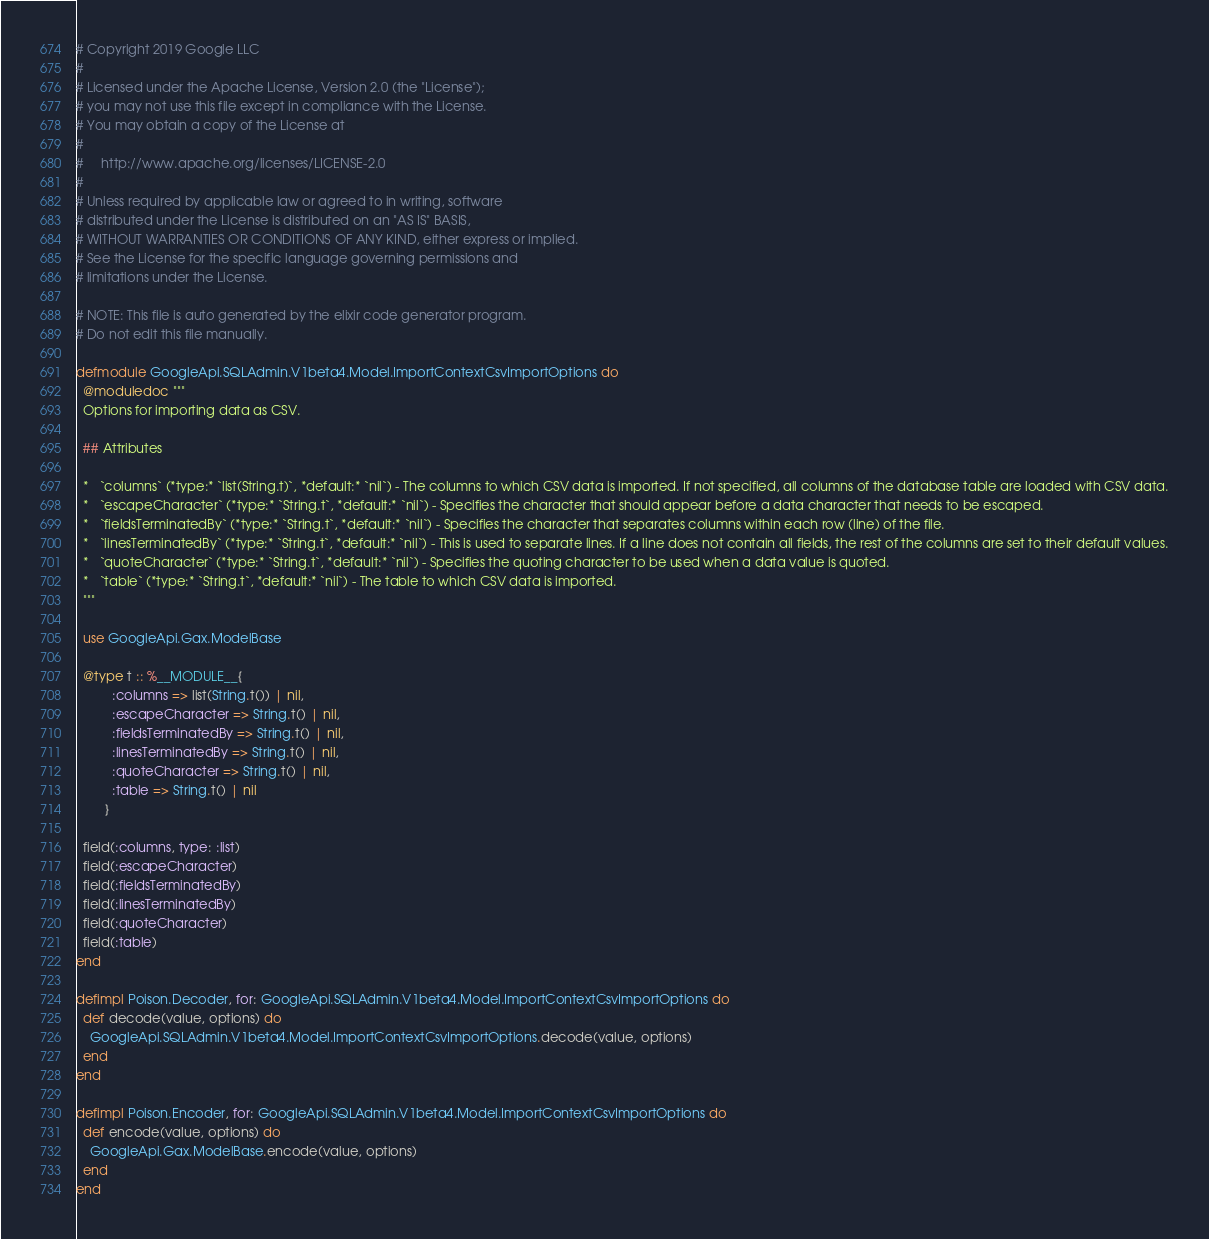Convert code to text. <code><loc_0><loc_0><loc_500><loc_500><_Elixir_># Copyright 2019 Google LLC
#
# Licensed under the Apache License, Version 2.0 (the "License");
# you may not use this file except in compliance with the License.
# You may obtain a copy of the License at
#
#     http://www.apache.org/licenses/LICENSE-2.0
#
# Unless required by applicable law or agreed to in writing, software
# distributed under the License is distributed on an "AS IS" BASIS,
# WITHOUT WARRANTIES OR CONDITIONS OF ANY KIND, either express or implied.
# See the License for the specific language governing permissions and
# limitations under the License.

# NOTE: This file is auto generated by the elixir code generator program.
# Do not edit this file manually.

defmodule GoogleApi.SQLAdmin.V1beta4.Model.ImportContextCsvImportOptions do
  @moduledoc """
  Options for importing data as CSV.

  ## Attributes

  *   `columns` (*type:* `list(String.t)`, *default:* `nil`) - The columns to which CSV data is imported. If not specified, all columns of the database table are loaded with CSV data.
  *   `escapeCharacter` (*type:* `String.t`, *default:* `nil`) - Specifies the character that should appear before a data character that needs to be escaped.
  *   `fieldsTerminatedBy` (*type:* `String.t`, *default:* `nil`) - Specifies the character that separates columns within each row (line) of the file.
  *   `linesTerminatedBy` (*type:* `String.t`, *default:* `nil`) - This is used to separate lines. If a line does not contain all fields, the rest of the columns are set to their default values.
  *   `quoteCharacter` (*type:* `String.t`, *default:* `nil`) - Specifies the quoting character to be used when a data value is quoted.
  *   `table` (*type:* `String.t`, *default:* `nil`) - The table to which CSV data is imported.
  """

  use GoogleApi.Gax.ModelBase

  @type t :: %__MODULE__{
          :columns => list(String.t()) | nil,
          :escapeCharacter => String.t() | nil,
          :fieldsTerminatedBy => String.t() | nil,
          :linesTerminatedBy => String.t() | nil,
          :quoteCharacter => String.t() | nil,
          :table => String.t() | nil
        }

  field(:columns, type: :list)
  field(:escapeCharacter)
  field(:fieldsTerminatedBy)
  field(:linesTerminatedBy)
  field(:quoteCharacter)
  field(:table)
end

defimpl Poison.Decoder, for: GoogleApi.SQLAdmin.V1beta4.Model.ImportContextCsvImportOptions do
  def decode(value, options) do
    GoogleApi.SQLAdmin.V1beta4.Model.ImportContextCsvImportOptions.decode(value, options)
  end
end

defimpl Poison.Encoder, for: GoogleApi.SQLAdmin.V1beta4.Model.ImportContextCsvImportOptions do
  def encode(value, options) do
    GoogleApi.Gax.ModelBase.encode(value, options)
  end
end
</code> 